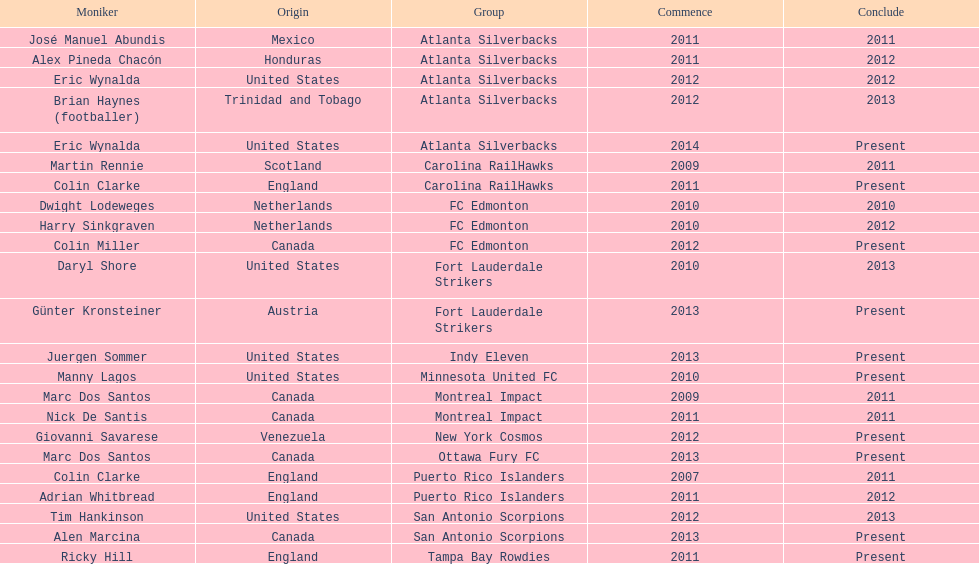How many total coaches on the list are from canada? 5. 